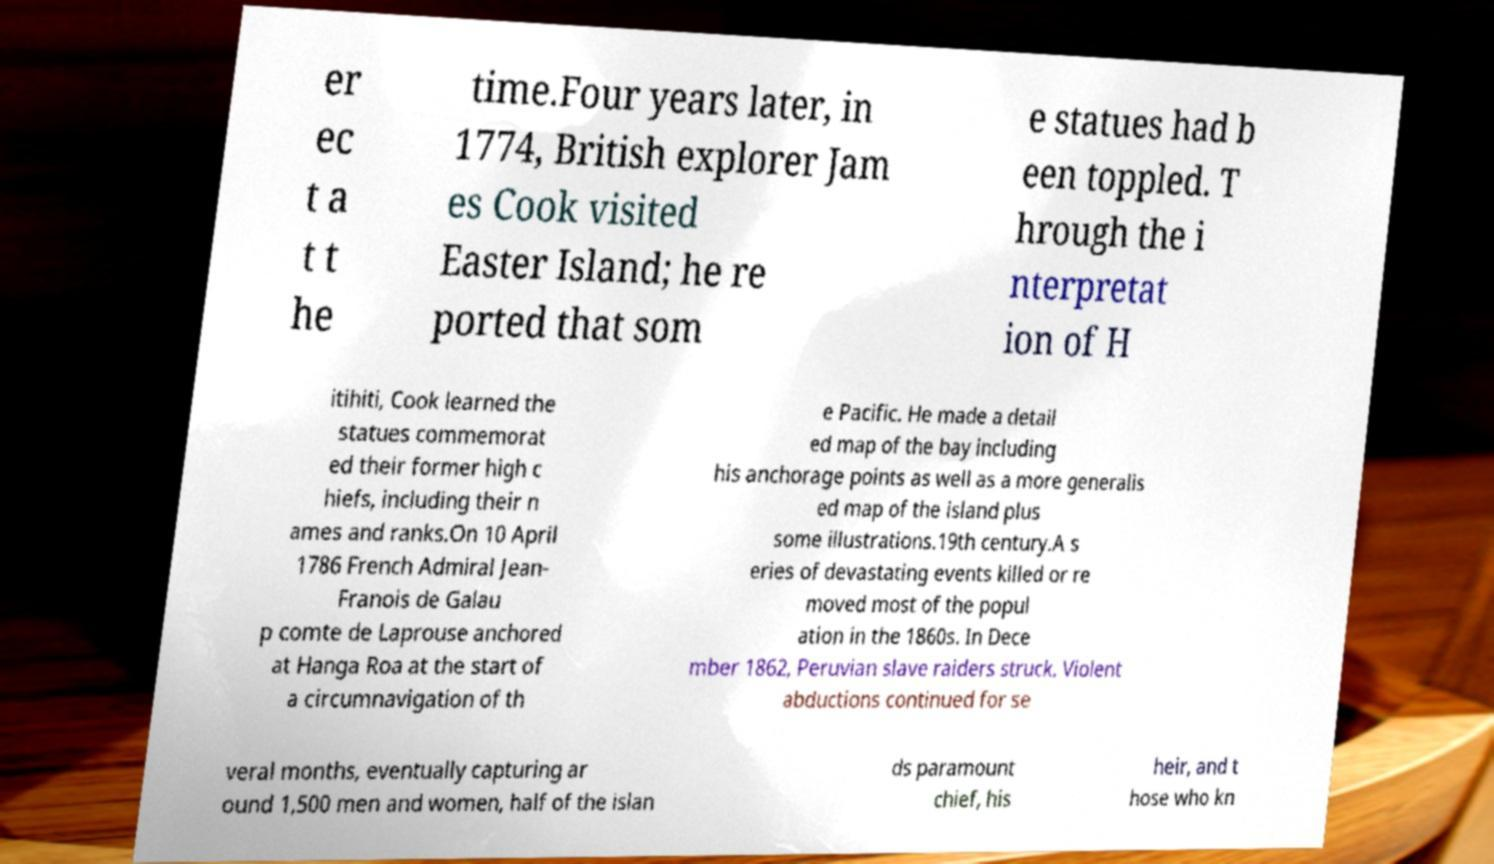Can you accurately transcribe the text from the provided image for me? er ec t a t t he time.Four years later, in 1774, British explorer Jam es Cook visited Easter Island; he re ported that som e statues had b een toppled. T hrough the i nterpretat ion of H itihiti, Cook learned the statues commemorat ed their former high c hiefs, including their n ames and ranks.On 10 April 1786 French Admiral Jean- Franois de Galau p comte de Laprouse anchored at Hanga Roa at the start of a circumnavigation of th e Pacific. He made a detail ed map of the bay including his anchorage points as well as a more generalis ed map of the island plus some illustrations.19th century.A s eries of devastating events killed or re moved most of the popul ation in the 1860s. In Dece mber 1862, Peruvian slave raiders struck. Violent abductions continued for se veral months, eventually capturing ar ound 1,500 men and women, half of the islan ds paramount chief, his heir, and t hose who kn 